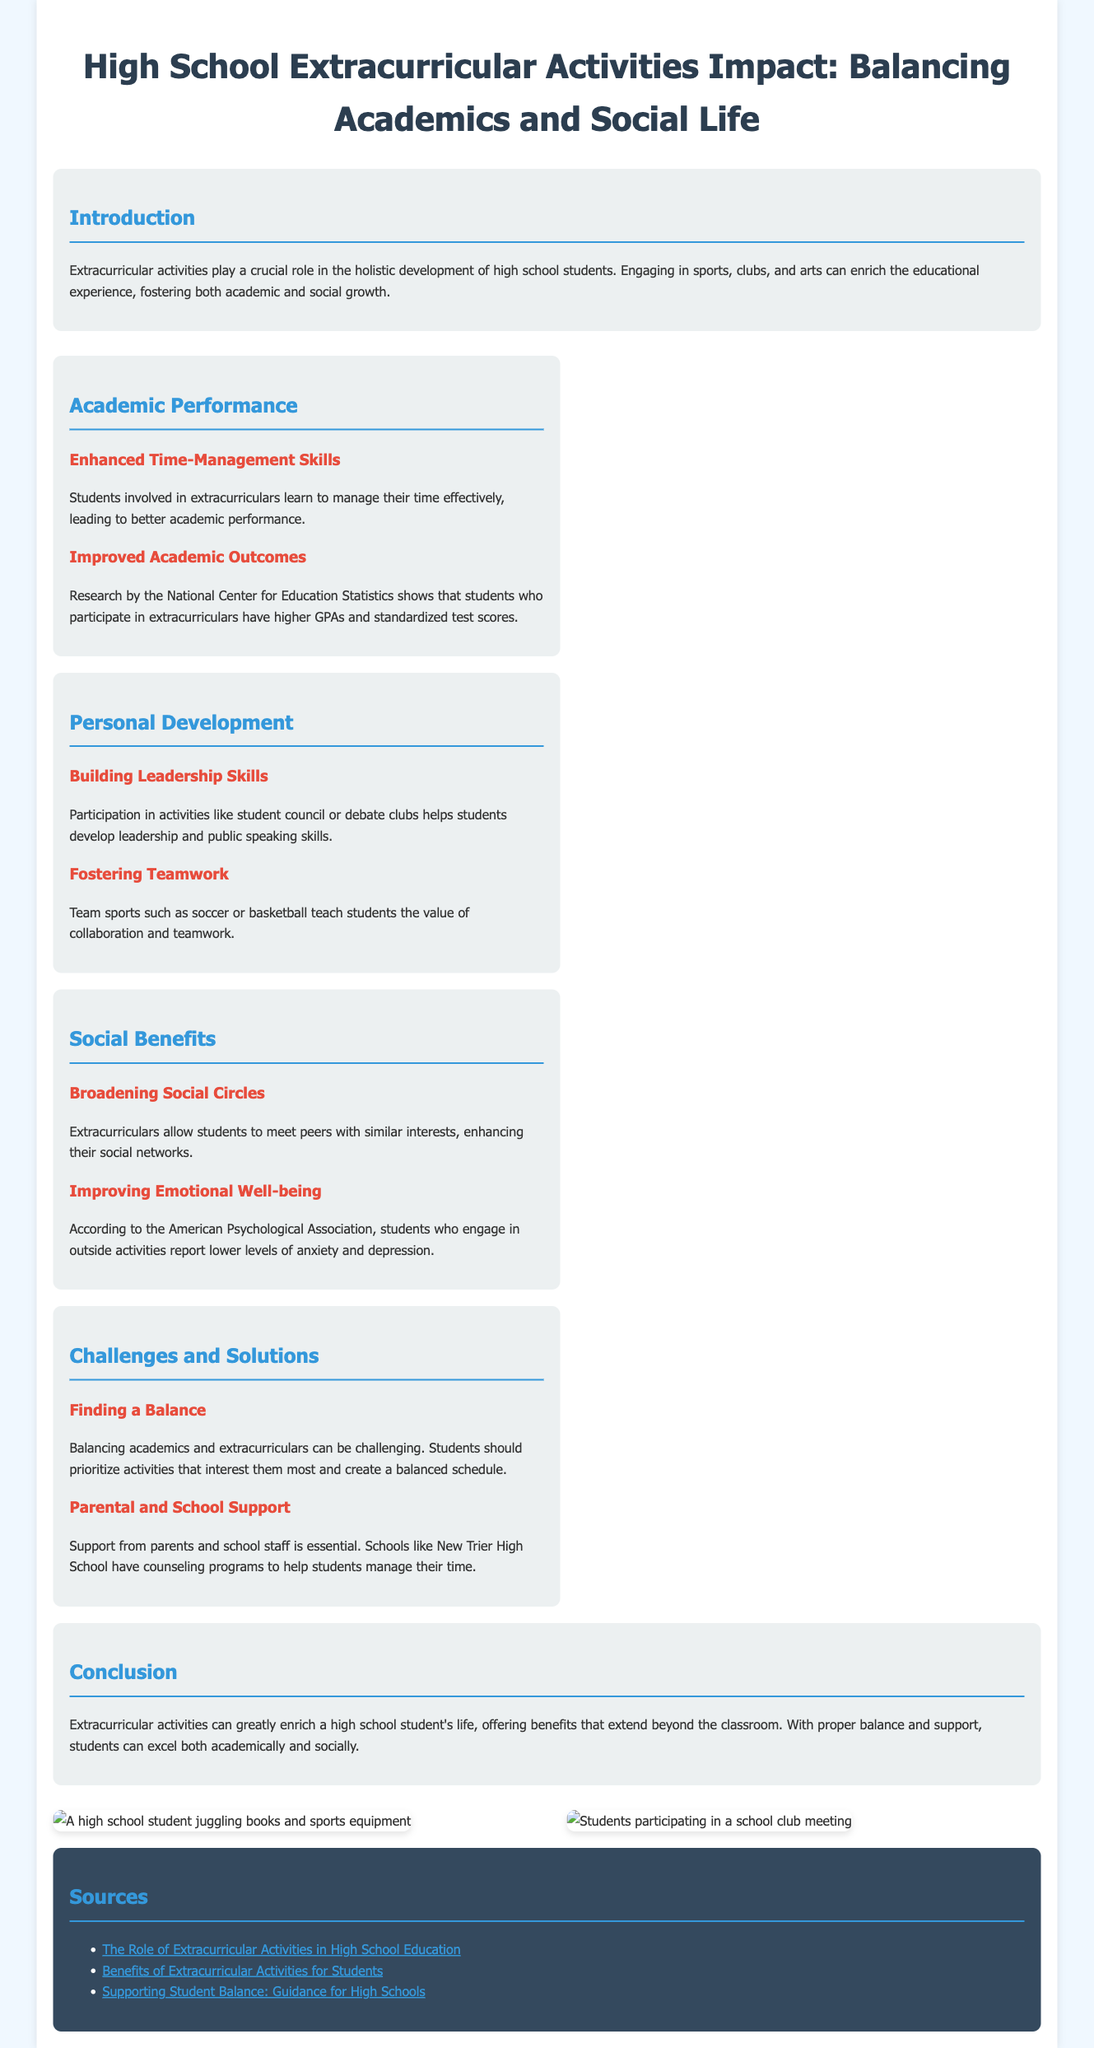What is the primary role of extracurricular activities in high school? The document states that extracurricular activities play a crucial role in the holistic development of high school students.
Answer: Holistic development What do students gain from improved time-management skills? Improved time-management skills lead to better academic performance as noted in the document.
Answer: Better academic performance Which organization conducted research on academic outcomes related to extracurriculars? The document references the National Center for Education Statistics as the organization conducting research on academic outcomes.
Answer: National Center for Education Statistics What benefit do team sports teach students? The document mentions that team sports teach students the value of collaboration and teamwork.
Answer: Collaboration and teamwork How can students manage the balance between academics and extracurriculars? Students should prioritize activities that interest them most and create a balanced schedule according to the document.
Answer: Create a balanced schedule What emotional benefit is associated with participation in outside activities? Students who engage in outside activities report lower levels of anxiety and depression, according to the document.
Answer: Lower levels of anxiety and depression What does New Trier High School provide to support students? The document states that New Trier High School has counseling programs to help students manage their time.
Answer: Counseling programs What is a key benefit of broadening social circles through extracurriculars? The document indicates that this enhances students' social networks.
Answer: Enhances social networks What is the conclusion of the infographic regarding extracurricular activities? The conclusion states that extracurricular activities can greatly enrich a high school student's life, offering benefits that extend beyond the classroom.
Answer: Enrich a high school student's life 